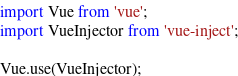Convert code to text. <code><loc_0><loc_0><loc_500><loc_500><_JavaScript_>import Vue from 'vue';
import VueInjector from 'vue-inject';

Vue.use(VueInjector);
</code> 